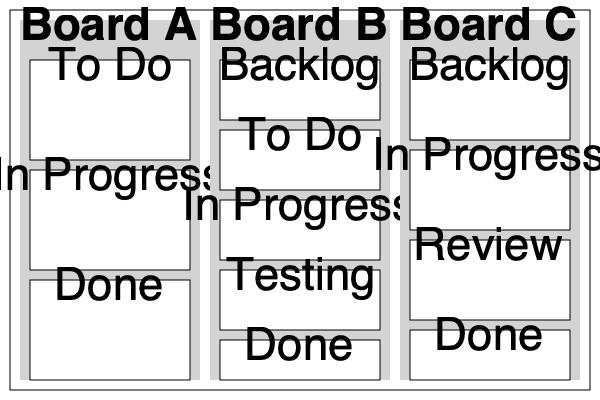Which Kanban-style board layout is most suitable for an agile project management approach in a company transitioning from traditional methods to more digital and agile practices? To determine the most suitable Kanban-style board layout for a company transitioning to agile practices, we need to analyze each board:

1. Board A:
   - Simple three-column layout: To Do, In Progress, Done
   - Pros: Easy to understand for beginners
   - Cons: Lacks granularity and may not capture all stages of work

2. Board B:
   - Five-column layout: Backlog, To Do, In Progress, Testing, Done
   - Pros:
     a) Includes a Backlog column for upcoming work
     b) Separates To Do from Backlog, allowing for better sprint planning
     c) Includes a Testing column, emphasizing quality assurance
     d) Provides a more detailed workflow
   - Cons: Slightly more complex, but still easy to understand

3. Board C:
   - Four-column layout: Backlog, In Progress, Review, Done
   - Pros: Includes a Review column, which can be useful for code reviews or general task reviews
   - Cons: Lacks a separate To Do column, which may make sprint planning less clear

For a company transitioning from traditional methods to agile practices, Board B offers the best balance of detail and simplicity. It provides:
1. A clear view of upcoming work (Backlog)
2. A defined sprint or iteration plan (To Do)
3. Visibility into work in progress (In Progress)
4. Emphasis on quality assurance (Testing)
5. A clear definition of completed work (Done)

This layout allows for better workflow visualization, supports sprint planning, and emphasizes testing, which are all crucial elements in adopting agile practices.
Answer: Board B 